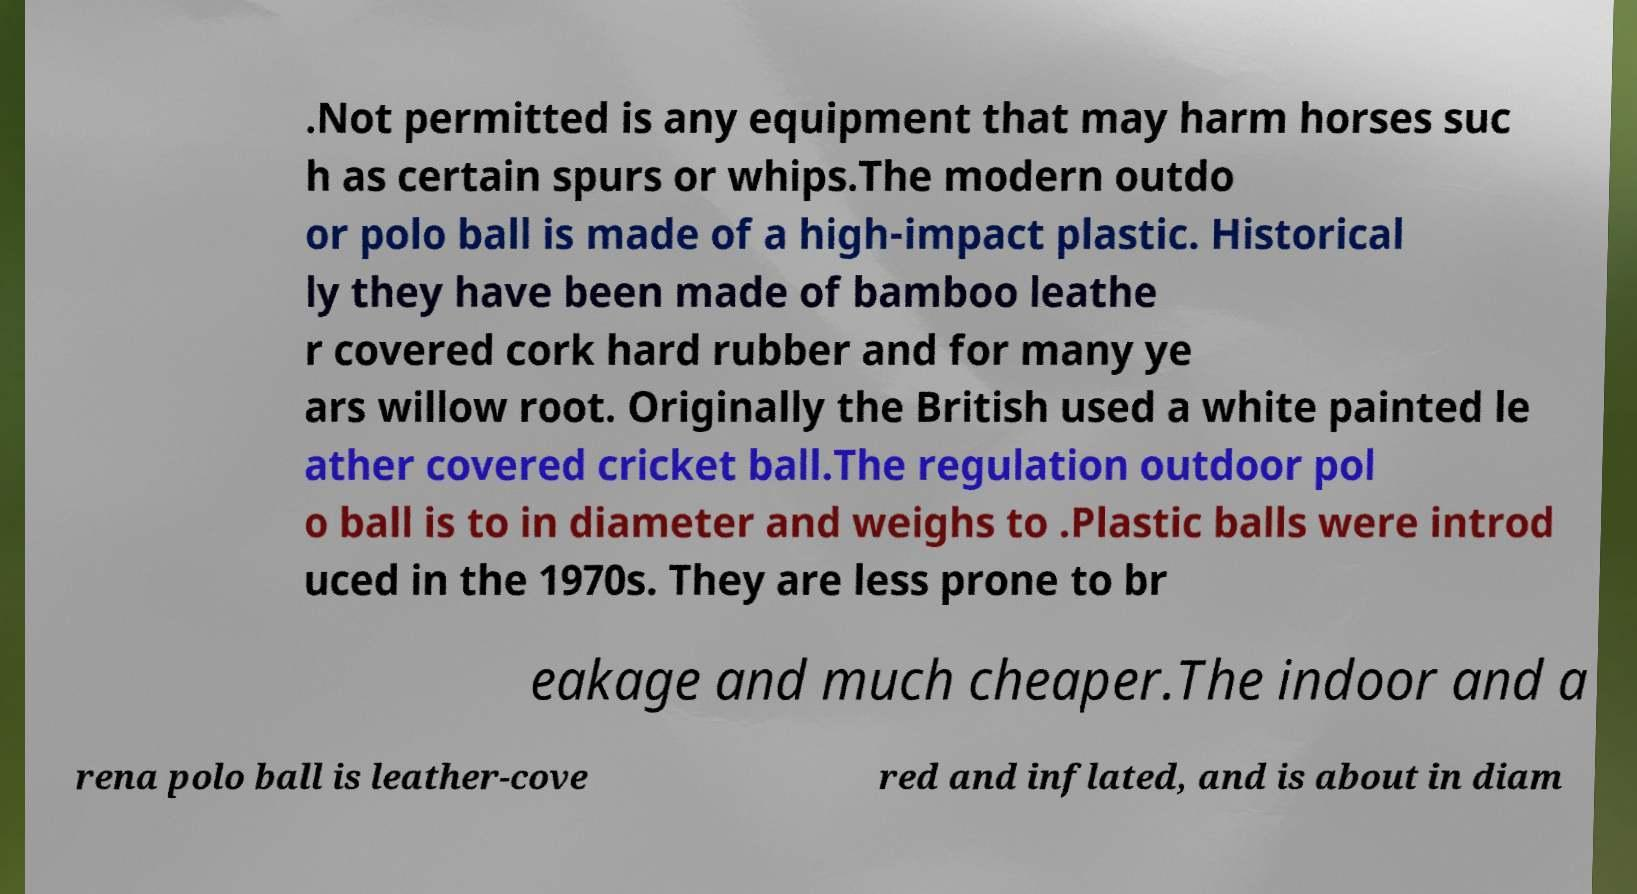There's text embedded in this image that I need extracted. Can you transcribe it verbatim? .Not permitted is any equipment that may harm horses suc h as certain spurs or whips.The modern outdo or polo ball is made of a high-impact plastic. Historical ly they have been made of bamboo leathe r covered cork hard rubber and for many ye ars willow root. Originally the British used a white painted le ather covered cricket ball.The regulation outdoor pol o ball is to in diameter and weighs to .Plastic balls were introd uced in the 1970s. They are less prone to br eakage and much cheaper.The indoor and a rena polo ball is leather-cove red and inflated, and is about in diam 